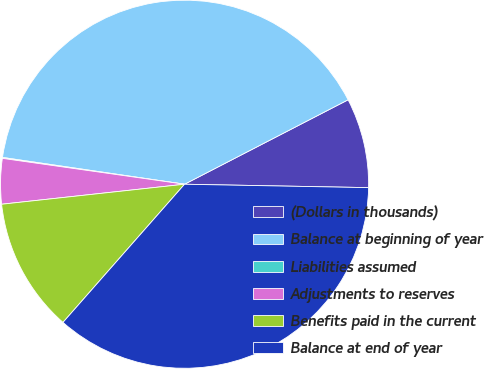Convert chart. <chart><loc_0><loc_0><loc_500><loc_500><pie_chart><fcel>(Dollars in thousands)<fcel>Balance at beginning of year<fcel>Liabilities assumed<fcel>Adjustments to reserves<fcel>Benefits paid in the current<fcel>Balance at end of year<nl><fcel>7.88%<fcel>40.09%<fcel>0.08%<fcel>3.98%<fcel>11.78%<fcel>36.19%<nl></chart> 